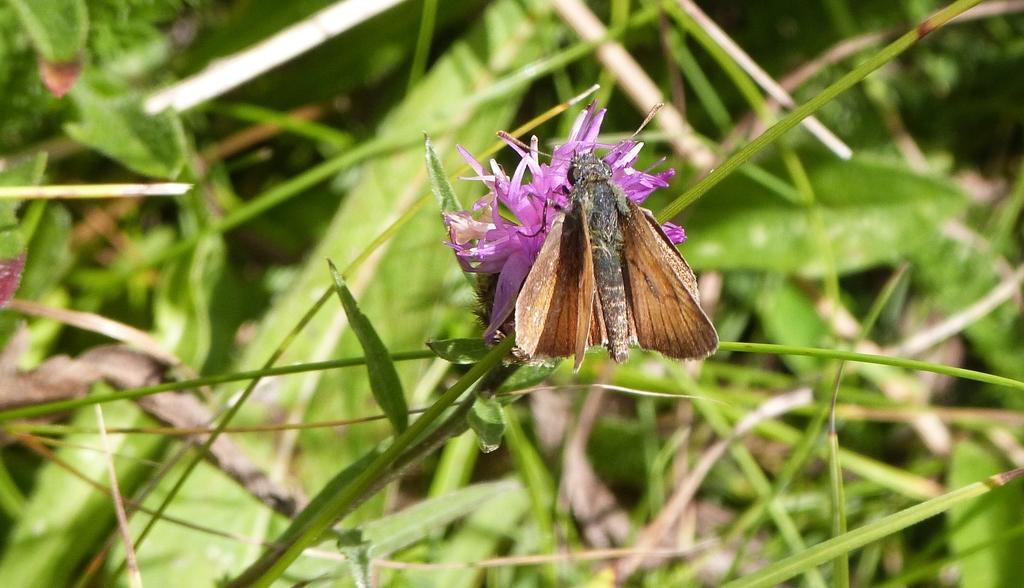How would you summarize this image in a sentence or two? In the center of the image we can see a fly on the flower. At the bottom there is grass. In the background there are plants. 